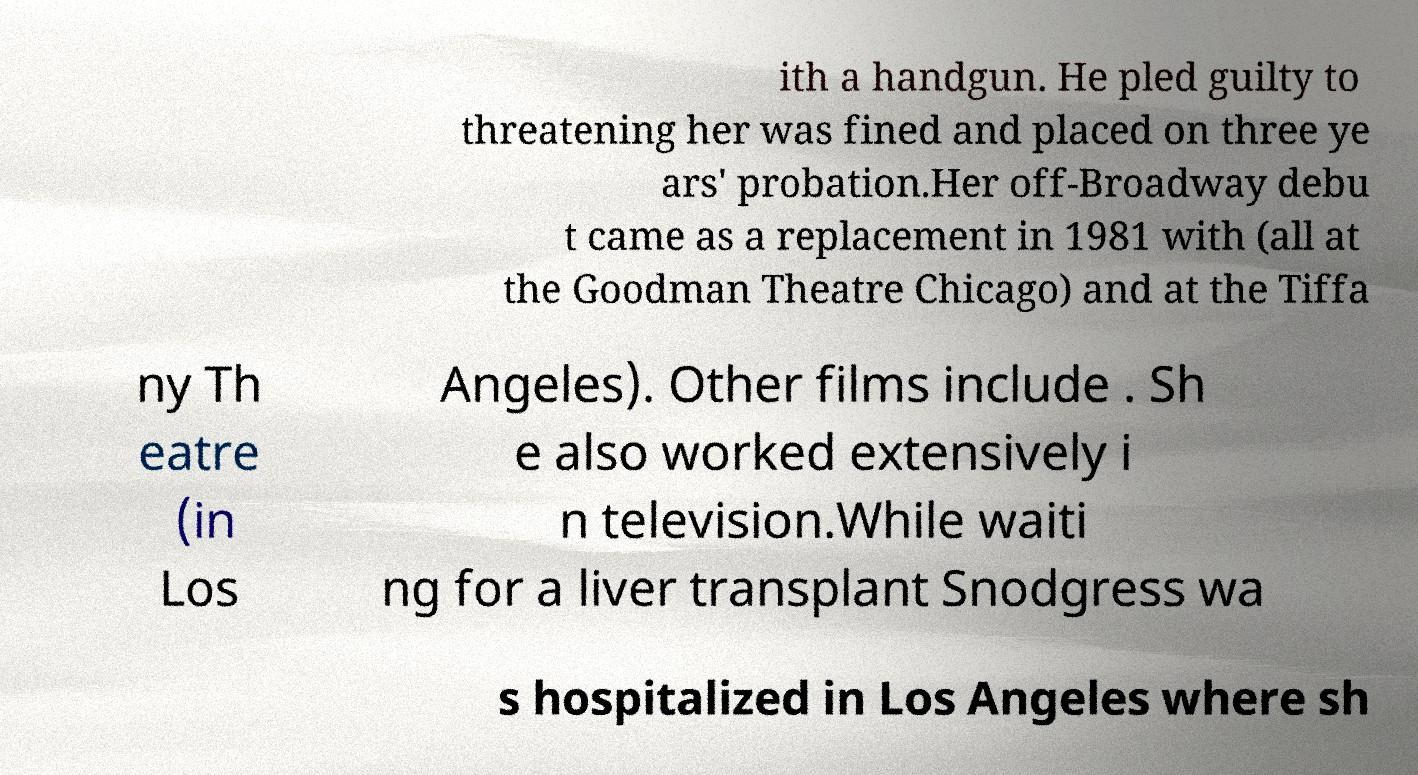Please read and relay the text visible in this image. What does it say? ith a handgun. He pled guilty to threatening her was fined and placed on three ye ars' probation.Her off-Broadway debu t came as a replacement in 1981 with (all at the Goodman Theatre Chicago) and at the Tiffa ny Th eatre (in Los Angeles). Other films include . Sh e also worked extensively i n television.While waiti ng for a liver transplant Snodgress wa s hospitalized in Los Angeles where sh 